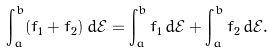Convert formula to latex. <formula><loc_0><loc_0><loc_500><loc_500>\int _ { a } ^ { b } ( f _ { 1 } + f _ { 2 } ) \, d \mathcal { E } = \int _ { a } ^ { b } f _ { 1 } \, d \mathcal { E } + \int _ { a } ^ { b } f _ { 2 } \, d \mathcal { E } .</formula> 